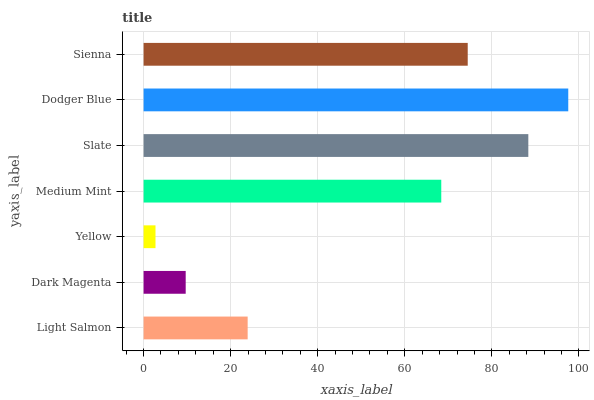Is Yellow the minimum?
Answer yes or no. Yes. Is Dodger Blue the maximum?
Answer yes or no. Yes. Is Dark Magenta the minimum?
Answer yes or no. No. Is Dark Magenta the maximum?
Answer yes or no. No. Is Light Salmon greater than Dark Magenta?
Answer yes or no. Yes. Is Dark Magenta less than Light Salmon?
Answer yes or no. Yes. Is Dark Magenta greater than Light Salmon?
Answer yes or no. No. Is Light Salmon less than Dark Magenta?
Answer yes or no. No. Is Medium Mint the high median?
Answer yes or no. Yes. Is Medium Mint the low median?
Answer yes or no. Yes. Is Light Salmon the high median?
Answer yes or no. No. Is Light Salmon the low median?
Answer yes or no. No. 